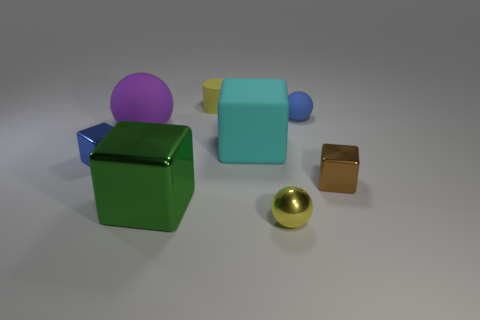What shape is the tiny brown shiny object?
Keep it short and to the point. Cube. What is the size of the metallic thing that is both in front of the tiny brown cube and to the right of the large green thing?
Your response must be concise. Small. What is the tiny yellow thing in front of the brown thing made of?
Ensure brevity in your answer.  Metal. There is a metal ball; does it have the same color as the big rubber thing on the left side of the green shiny block?
Keep it short and to the point. No. How many things are either small blocks that are to the right of the yellow cylinder or shiny blocks that are left of the big metal thing?
Provide a short and direct response. 2. What color is the object that is to the right of the cyan block and in front of the small brown object?
Provide a succinct answer. Yellow. Is the number of blue rubber balls greater than the number of small blue matte blocks?
Give a very brief answer. Yes. There is a large object that is behind the matte block; is its shape the same as the green metallic thing?
Your answer should be very brief. No. How many rubber things are brown blocks or tiny gray cylinders?
Your response must be concise. 0. Are there any tiny cylinders made of the same material as the brown object?
Ensure brevity in your answer.  No. 